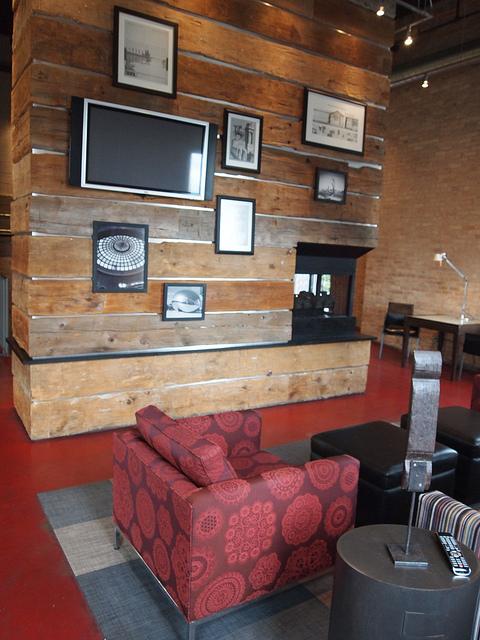Is that carpet orange?
Quick response, please. No. How would you describe the TV on the wall?
Keep it brief. Flat screen. What color is the chair?
Quick response, please. Red. 